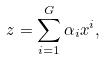<formula> <loc_0><loc_0><loc_500><loc_500>z = \sum _ { i = 1 } ^ { G } \alpha _ { i } x ^ { i } ,</formula> 